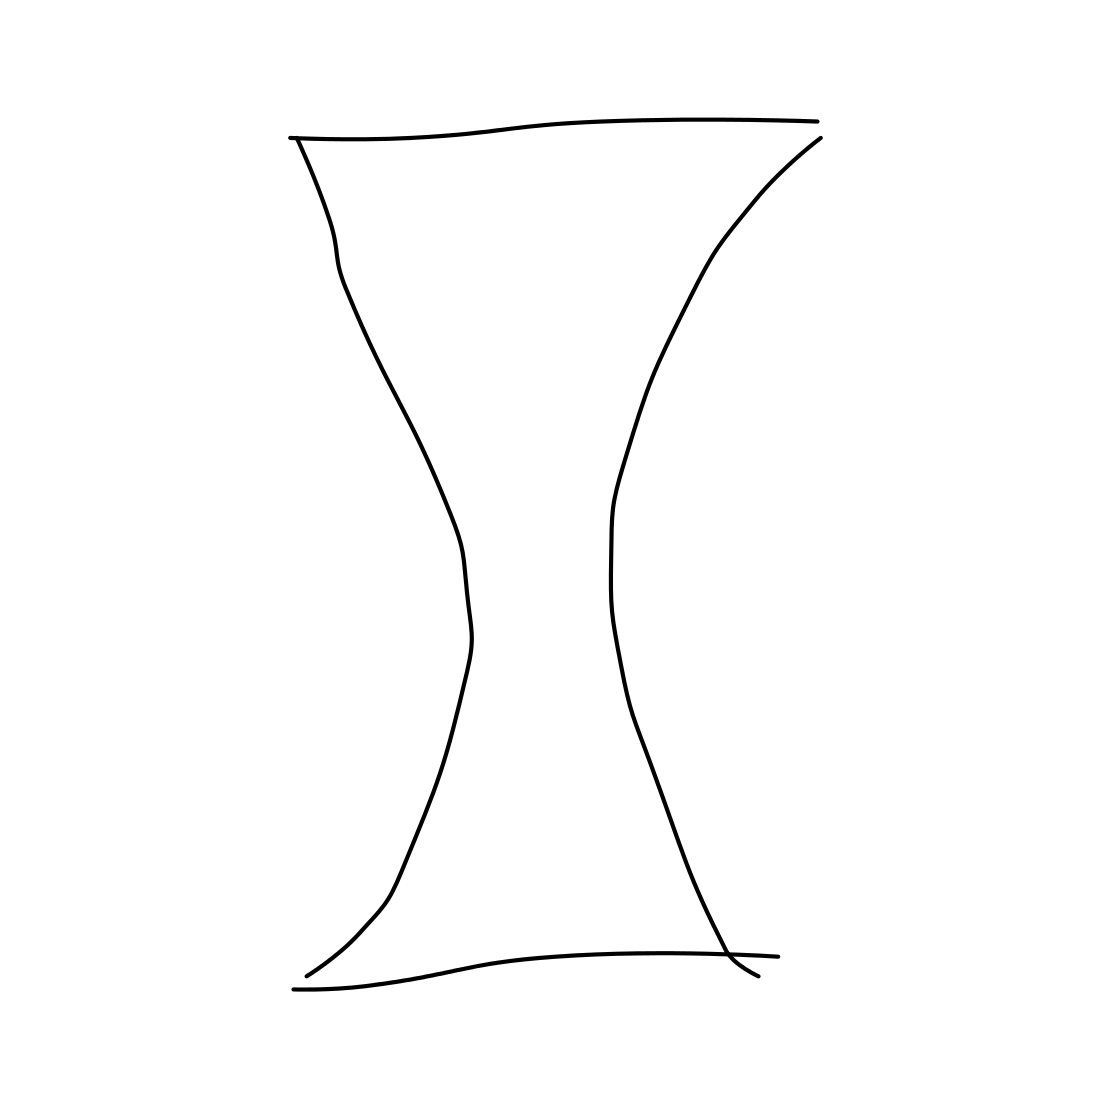Are there any mathematical properties to this shape that are worth mentioning? The shape has a symmetry that suggests it could be mathematically described with specific equations, particularly those related to conic sections. This curvature implies that the sides of the shapes are parts of hyperbolas or parabolas, which have distinct mathematical properties and equations. 